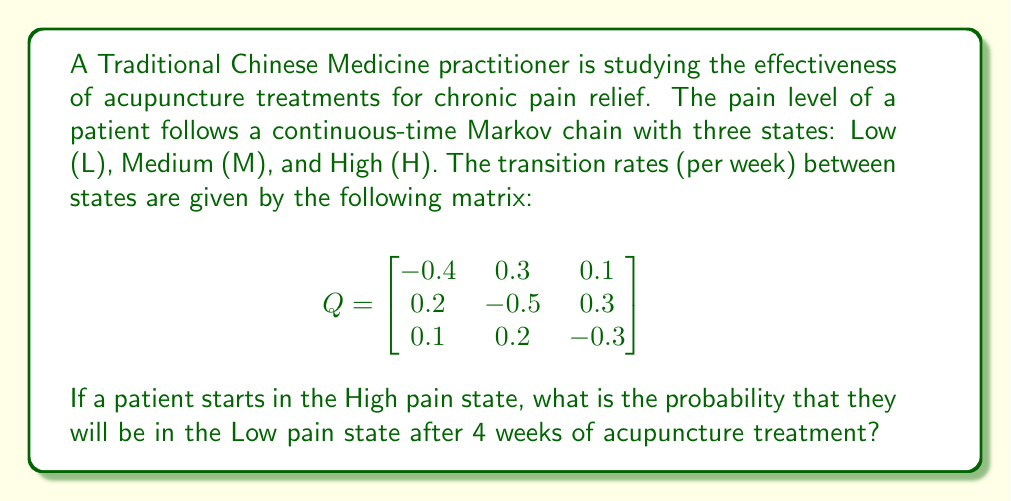Show me your answer to this math problem. To solve this problem, we need to follow these steps:

1) First, we need to calculate the transition probability matrix $P(t)$ for $t = 4$ weeks. We can do this using the formula:

   $$P(t) = e^{Qt}$$

   where $e^{Qt}$ is the matrix exponential.

2) To calculate the matrix exponential, we can use the eigendecomposition method:

   $$e^{Qt} = S e^{\Lambda t} S^{-1}$$

   where $S$ is the matrix of eigenvectors and $\Lambda$ is the diagonal matrix of eigenvalues.

3) Calculate the eigenvalues and eigenvectors of $Q$:
   
   Eigenvalues: $\lambda_1 = 0$, $\lambda_2 \approx -0.5858$, $\lambda_3 \approx -0.6142$

   Eigenvectors:
   $$S \approx \begin{bmatrix}
   0.5774 & -0.7071 & 0.4082 \\
   0.5774 & 0.0000 & -0.8165 \\
   0.5774 & 0.7071 & 0.4082
   \end{bmatrix}$$

4) Calculate $e^{\Lambda t}$:
   $$e^{\Lambda t} = \begin{bmatrix}
   1 & 0 & 0 \\
   0 & e^{-0.5858t} & 0 \\
   0 & 0 & e^{-0.6142t}
   \end{bmatrix}$$

5) Calculate $P(4) = S e^{\Lambda 4} S^{-1}$:
   $$P(4) \approx \begin{bmatrix}
   0.4396 & 0.3604 & 0.2000 \\
   0.3208 & 0.4084 & 0.2708 \\
   0.2990 & 0.3510 & 0.3500
   \end{bmatrix}$$

6) The probability of transitioning from High (H) to Low (L) after 4 weeks is given by the element in the 3rd row and 1st column of $P(4)$, which is approximately 0.2990.
Answer: 0.2990 